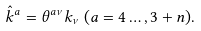Convert formula to latex. <formula><loc_0><loc_0><loc_500><loc_500>\hat { k } ^ { a } = \theta ^ { a \nu } k _ { \nu } \, ( a = 4 \dots , 3 + n ) .</formula> 